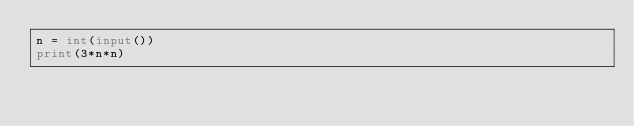Convert code to text. <code><loc_0><loc_0><loc_500><loc_500><_Python_>n = int(input())
print(3*n*n)</code> 